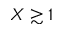Convert formula to latex. <formula><loc_0><loc_0><loc_500><loc_500>X \gtrsim 1</formula> 